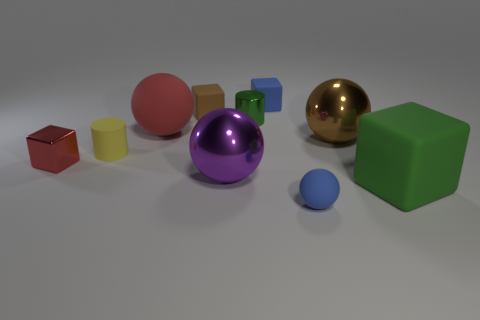What material is the big object that is the same color as the metal cube?
Offer a very short reply. Rubber. There is a matte block in front of the tiny metal block; is its color the same as the small matte cylinder?
Your response must be concise. No. What number of blue rubber cubes are right of the big shiny sphere that is to the left of the small blue rubber object that is in front of the tiny red metallic cube?
Provide a succinct answer. 1. What number of large red rubber spheres are in front of the large green rubber block?
Your answer should be compact. 0. There is another big metallic thing that is the same shape as the big purple thing; what color is it?
Provide a short and direct response. Brown. What is the material of the thing that is both in front of the yellow rubber object and left of the red matte ball?
Give a very brief answer. Metal. Does the shiny cylinder behind the brown metallic sphere have the same size as the big red matte thing?
Ensure brevity in your answer.  No. What is the red ball made of?
Your answer should be very brief. Rubber. What color is the metallic object that is in front of the metallic block?
Make the answer very short. Purple. What number of big things are either blue cubes or shiny things?
Offer a terse response. 2. 